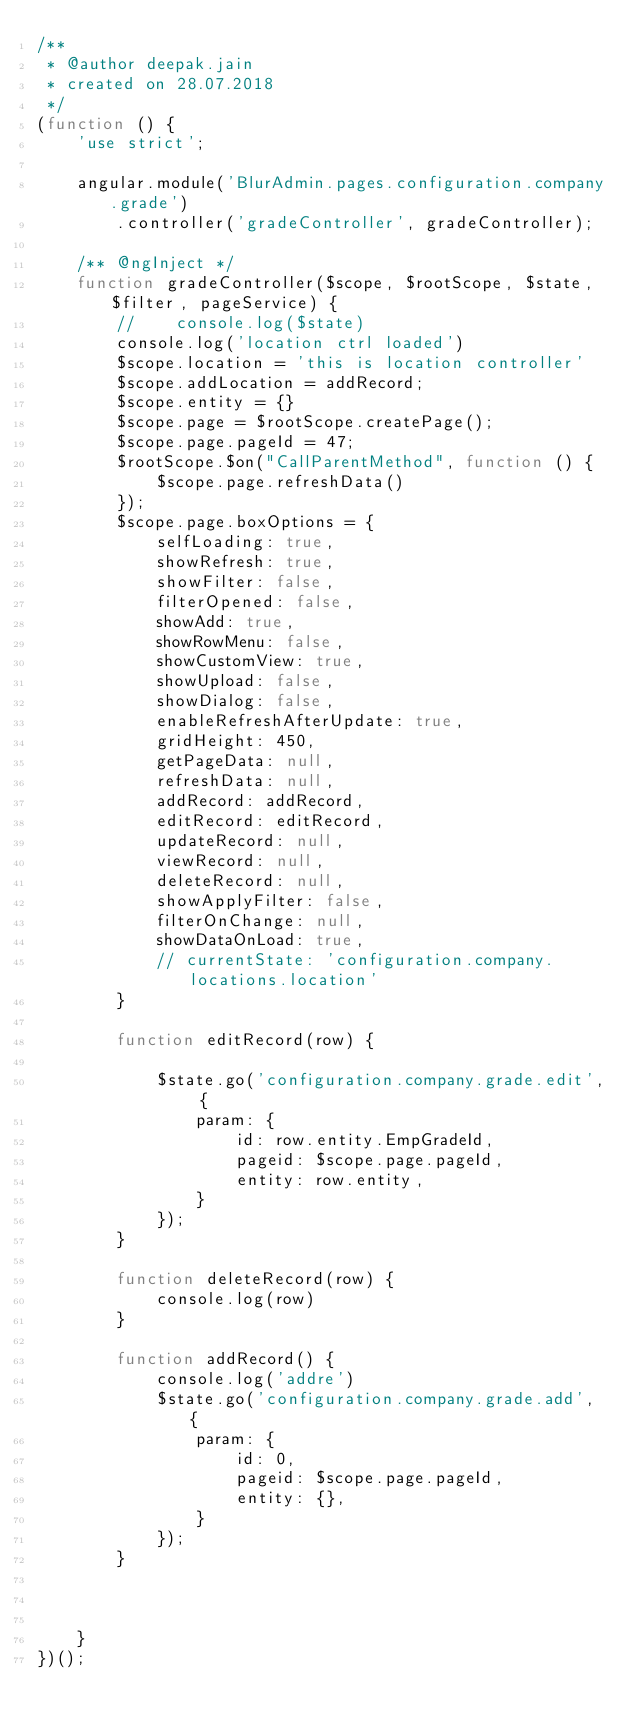Convert code to text. <code><loc_0><loc_0><loc_500><loc_500><_JavaScript_>/**
 * @author deepak.jain
 * created on 28.07.2018
 */
(function () {
    'use strict';

    angular.module('BlurAdmin.pages.configuration.company.grade')
        .controller('gradeController', gradeController);

    /** @ngInject */
    function gradeController($scope, $rootScope, $state, $filter, pageService) {
        //    console.log($state)
        console.log('location ctrl loaded')
        $scope.location = 'this is location controller'
        $scope.addLocation = addRecord;
        $scope.entity = {}
        $scope.page = $rootScope.createPage();
        $scope.page.pageId = 47;
        $rootScope.$on("CallParentMethod", function () {
            $scope.page.refreshData()
        });
        $scope.page.boxOptions = {
            selfLoading: true,
            showRefresh: true,
            showFilter: false,
            filterOpened: false,
            showAdd: true,
            showRowMenu: false,
            showCustomView: true,
            showUpload: false,
            showDialog: false,
            enableRefreshAfterUpdate: true,
            gridHeight: 450,
            getPageData: null,
            refreshData: null,
            addRecord: addRecord,
            editRecord: editRecord,
            updateRecord: null,
            viewRecord: null,
            deleteRecord: null,
            showApplyFilter: false,
            filterOnChange: null,
            showDataOnLoad: true,
            // currentState: 'configuration.company.locations.location'
        }

        function editRecord(row) {

            $state.go('configuration.company.grade.edit', {
                param: {
                    id: row.entity.EmpGradeId,
                    pageid: $scope.page.pageId,
                    entity: row.entity,
                }
            });
        }

        function deleteRecord(row) {
            console.log(row)
        }

        function addRecord() {
            console.log('addre')
            $state.go('configuration.company.grade.add', {
                param: {
                    id: 0,
                    pageid: $scope.page.pageId,
                    entity: {},
                }
            });
        }



    }
})();</code> 